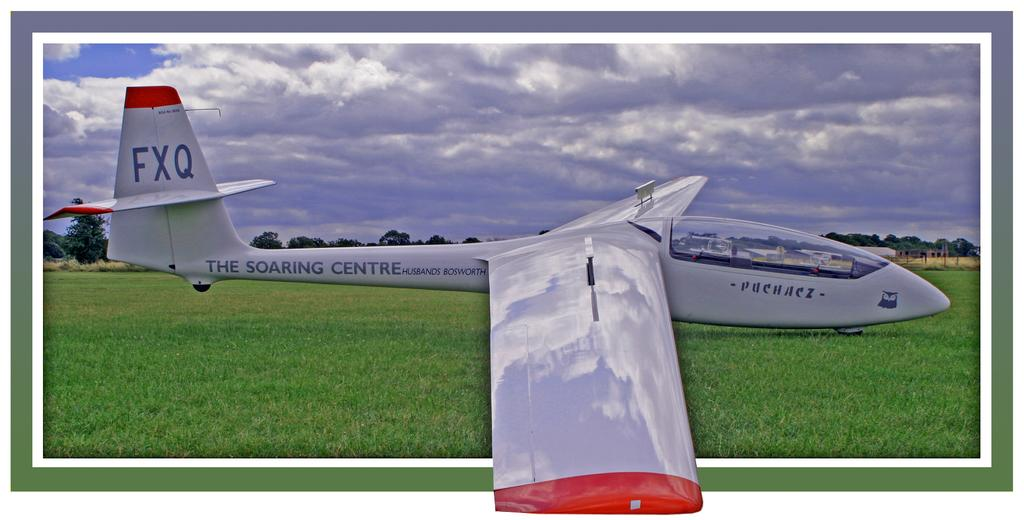<image>
Relay a brief, clear account of the picture shown. a grey and red aircraft with the letters FXQ on the back wing. 